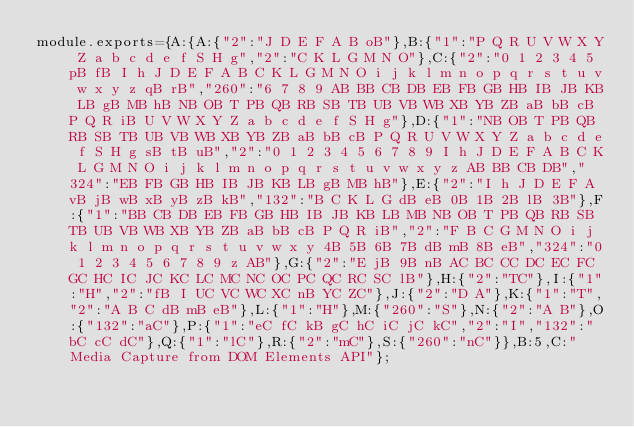<code> <loc_0><loc_0><loc_500><loc_500><_JavaScript_>module.exports={A:{A:{"2":"J D E F A B oB"},B:{"1":"P Q R U V W X Y Z a b c d e f S H g","2":"C K L G M N O"},C:{"2":"0 1 2 3 4 5 pB fB I h J D E F A B C K L G M N O i j k l m n o p q r s t u v w x y z qB rB","260":"6 7 8 9 AB BB CB DB EB FB GB HB IB JB KB LB gB MB hB NB OB T PB QB RB SB TB UB VB WB XB YB ZB aB bB cB P Q R iB U V W X Y Z a b c d e f S H g"},D:{"1":"NB OB T PB QB RB SB TB UB VB WB XB YB ZB aB bB cB P Q R U V W X Y Z a b c d e f S H g sB tB uB","2":"0 1 2 3 4 5 6 7 8 9 I h J D E F A B C K L G M N O i j k l m n o p q r s t u v w x y z AB BB CB DB","324":"EB FB GB HB IB JB KB LB gB MB hB"},E:{"2":"I h J D E F A vB jB wB xB yB zB kB","132":"B C K L G dB eB 0B 1B 2B lB 3B"},F:{"1":"BB CB DB EB FB GB HB IB JB KB LB MB NB OB T PB QB RB SB TB UB VB WB XB YB ZB aB bB cB P Q R iB","2":"F B C G M N O i j k l m n o p q r s t u v w x y 4B 5B 6B 7B dB mB 8B eB","324":"0 1 2 3 4 5 6 7 8 9 z AB"},G:{"2":"E jB 9B nB AC BC CC DC EC FC GC HC IC JC KC LC MC NC OC PC QC RC SC lB"},H:{"2":"TC"},I:{"1":"H","2":"fB I UC VC WC XC nB YC ZC"},J:{"2":"D A"},K:{"1":"T","2":"A B C dB mB eB"},L:{"1":"H"},M:{"260":"S"},N:{"2":"A B"},O:{"132":"aC"},P:{"1":"eC fC kB gC hC iC jC kC","2":"I","132":"bC cC dC"},Q:{"1":"lC"},R:{"2":"mC"},S:{"260":"nC"}},B:5,C:"Media Capture from DOM Elements API"};
</code> 